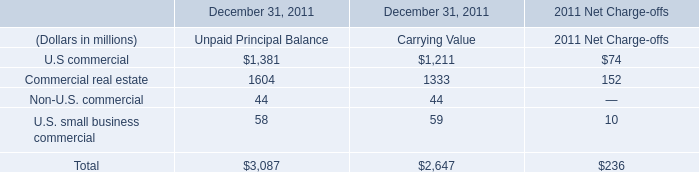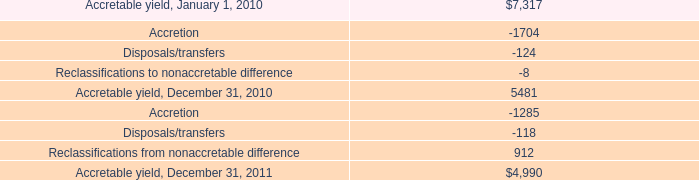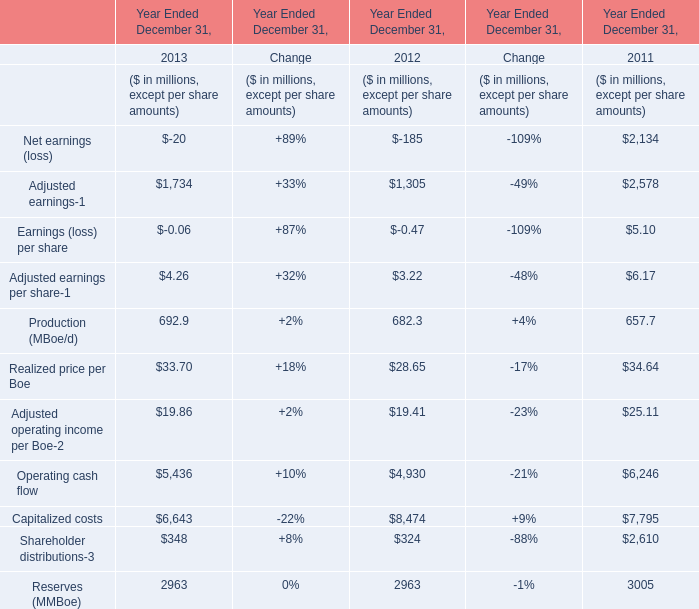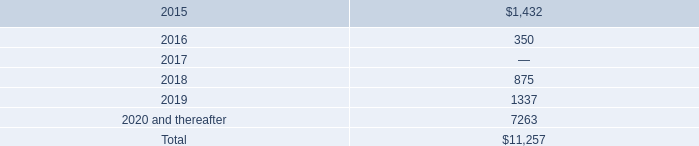What is the total amount of Accretable yield, December 31, 2010, and U.S commercial of December 31, 2011 Unpaid Principal Balance ? 
Computations: (5481.0 + 1381.0)
Answer: 6862.0. 